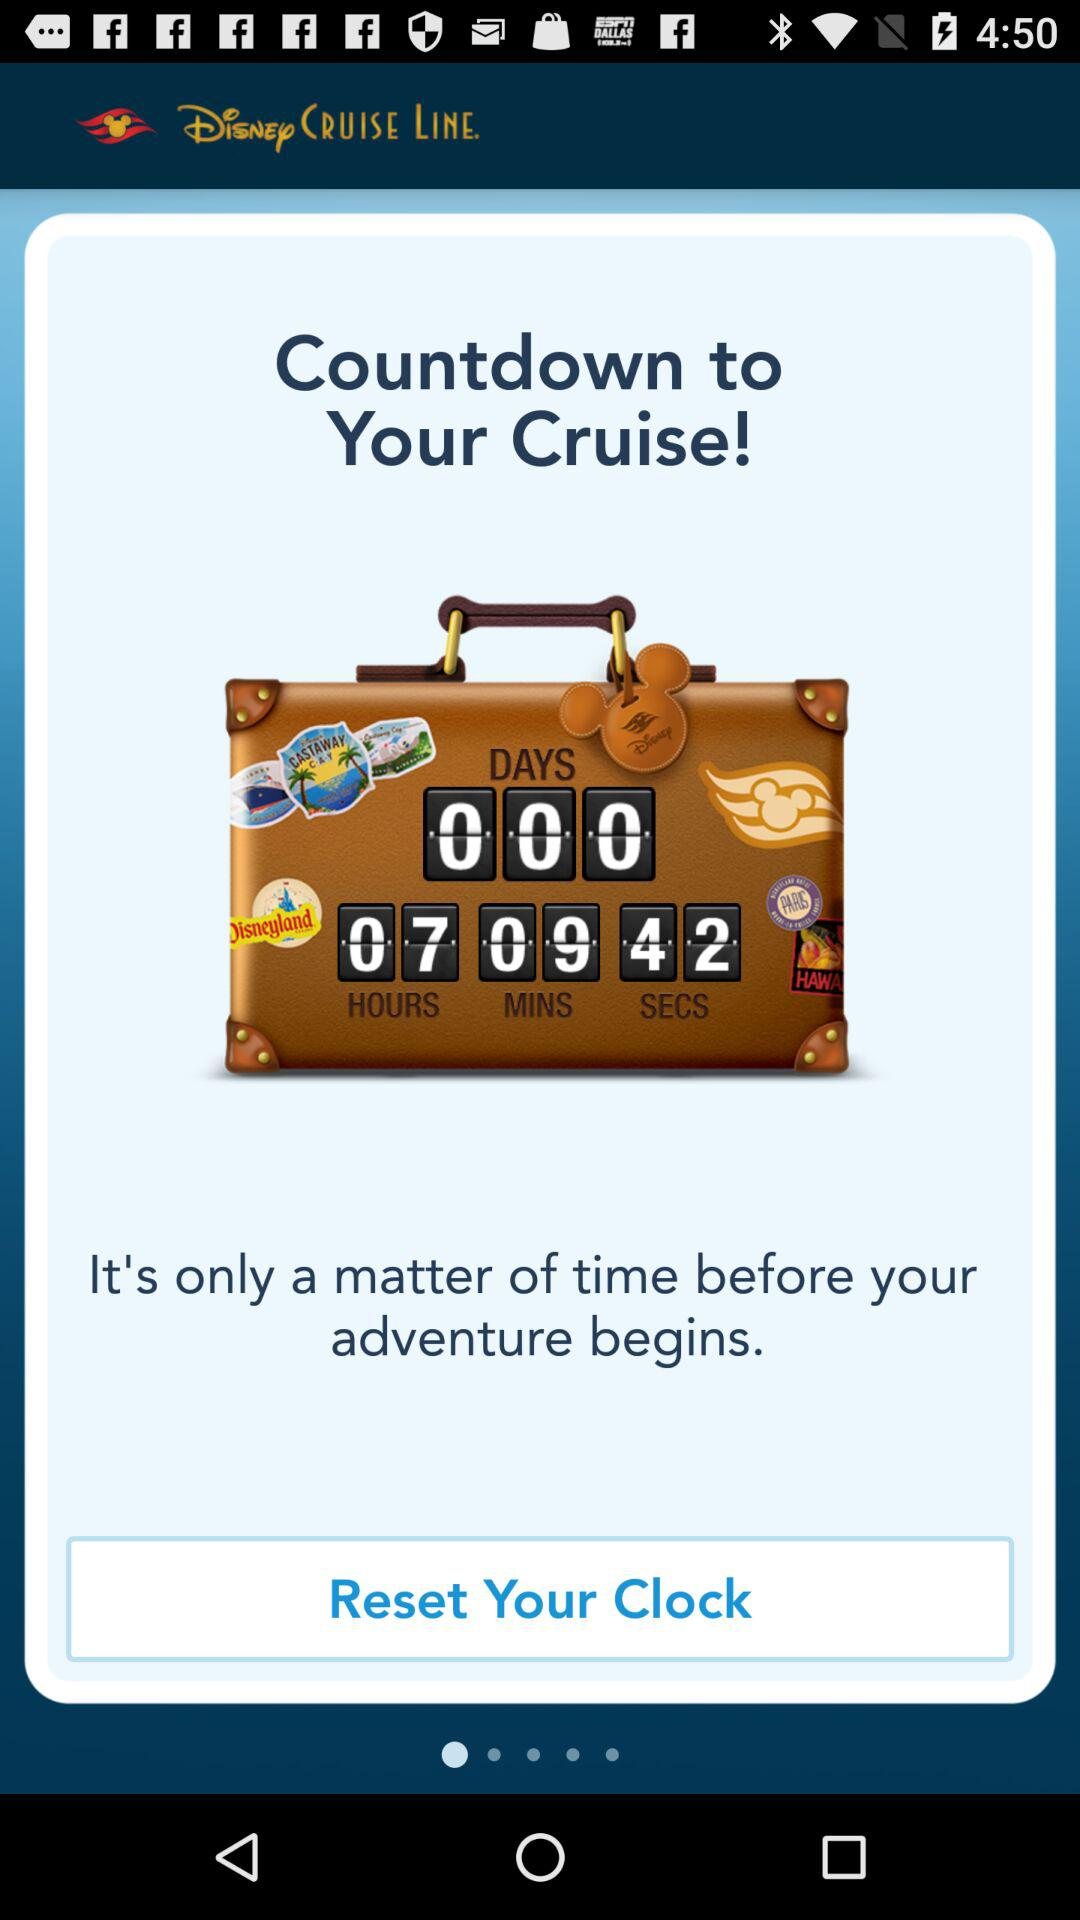What destinations are featured on the stickers on the suitcase? The suitcase features stickers from Disneyland, Walt Disney World, and Hawaii, reflecting some exciting places you might visit or recall during your cruise adventures. 